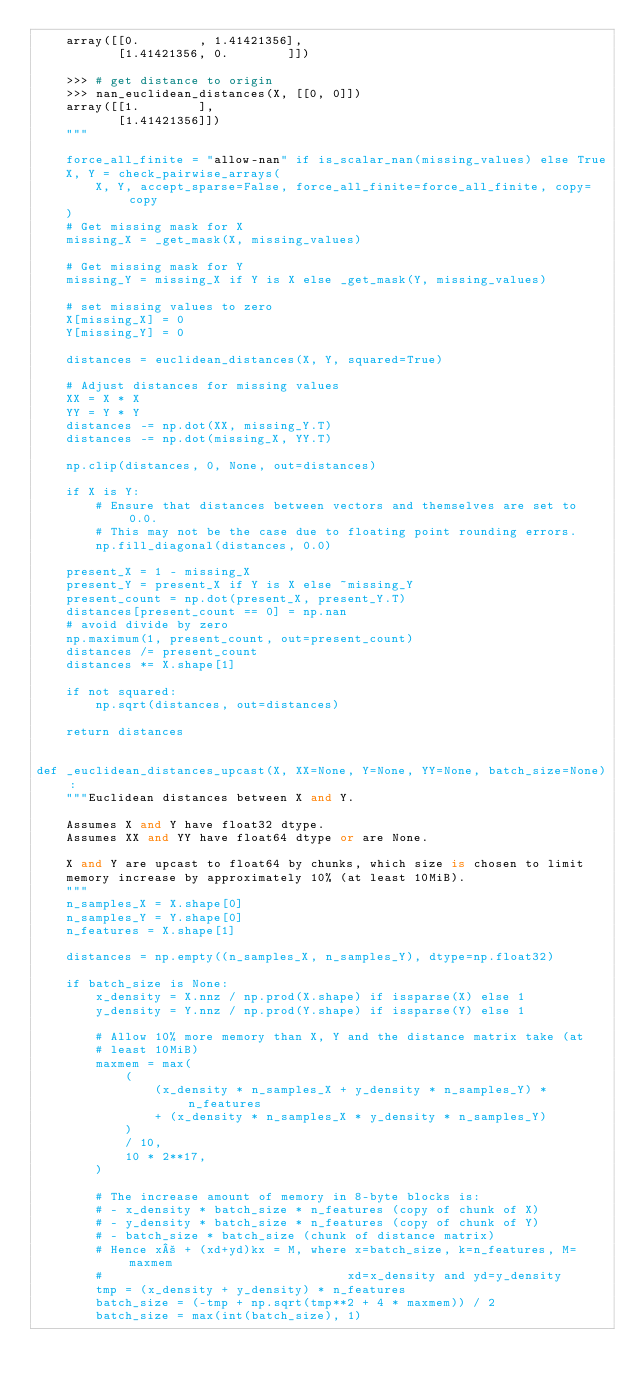Convert code to text. <code><loc_0><loc_0><loc_500><loc_500><_Python_>    array([[0.        , 1.41421356],
           [1.41421356, 0.        ]])

    >>> # get distance to origin
    >>> nan_euclidean_distances(X, [[0, 0]])
    array([[1.        ],
           [1.41421356]])
    """

    force_all_finite = "allow-nan" if is_scalar_nan(missing_values) else True
    X, Y = check_pairwise_arrays(
        X, Y, accept_sparse=False, force_all_finite=force_all_finite, copy=copy
    )
    # Get missing mask for X
    missing_X = _get_mask(X, missing_values)

    # Get missing mask for Y
    missing_Y = missing_X if Y is X else _get_mask(Y, missing_values)

    # set missing values to zero
    X[missing_X] = 0
    Y[missing_Y] = 0

    distances = euclidean_distances(X, Y, squared=True)

    # Adjust distances for missing values
    XX = X * X
    YY = Y * Y
    distances -= np.dot(XX, missing_Y.T)
    distances -= np.dot(missing_X, YY.T)

    np.clip(distances, 0, None, out=distances)

    if X is Y:
        # Ensure that distances between vectors and themselves are set to 0.0.
        # This may not be the case due to floating point rounding errors.
        np.fill_diagonal(distances, 0.0)

    present_X = 1 - missing_X
    present_Y = present_X if Y is X else ~missing_Y
    present_count = np.dot(present_X, present_Y.T)
    distances[present_count == 0] = np.nan
    # avoid divide by zero
    np.maximum(1, present_count, out=present_count)
    distances /= present_count
    distances *= X.shape[1]

    if not squared:
        np.sqrt(distances, out=distances)

    return distances


def _euclidean_distances_upcast(X, XX=None, Y=None, YY=None, batch_size=None):
    """Euclidean distances between X and Y.

    Assumes X and Y have float32 dtype.
    Assumes XX and YY have float64 dtype or are None.

    X and Y are upcast to float64 by chunks, which size is chosen to limit
    memory increase by approximately 10% (at least 10MiB).
    """
    n_samples_X = X.shape[0]
    n_samples_Y = Y.shape[0]
    n_features = X.shape[1]

    distances = np.empty((n_samples_X, n_samples_Y), dtype=np.float32)

    if batch_size is None:
        x_density = X.nnz / np.prod(X.shape) if issparse(X) else 1
        y_density = Y.nnz / np.prod(Y.shape) if issparse(Y) else 1

        # Allow 10% more memory than X, Y and the distance matrix take (at
        # least 10MiB)
        maxmem = max(
            (
                (x_density * n_samples_X + y_density * n_samples_Y) * n_features
                + (x_density * n_samples_X * y_density * n_samples_Y)
            )
            / 10,
            10 * 2**17,
        )

        # The increase amount of memory in 8-byte blocks is:
        # - x_density * batch_size * n_features (copy of chunk of X)
        # - y_density * batch_size * n_features (copy of chunk of Y)
        # - batch_size * batch_size (chunk of distance matrix)
        # Hence x² + (xd+yd)kx = M, where x=batch_size, k=n_features, M=maxmem
        #                                 xd=x_density and yd=y_density
        tmp = (x_density + y_density) * n_features
        batch_size = (-tmp + np.sqrt(tmp**2 + 4 * maxmem)) / 2
        batch_size = max(int(batch_size), 1)
</code> 